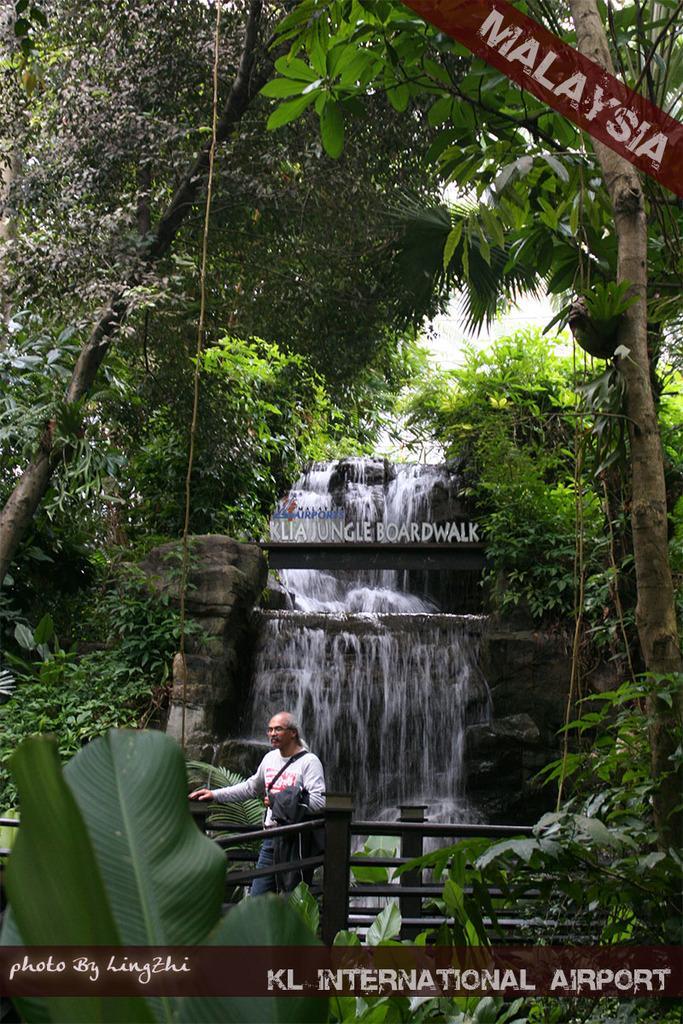How would you summarize this image in a sentence or two? The man in white T-shirt and blue jeans is walking on the bridge. Beside him, we see an iron railing. Behind him, there is a waterfall. There are trees in the background and we even see a building. In the right top of the picture, we see a board in red color with "MALAYSIA" written on it. 